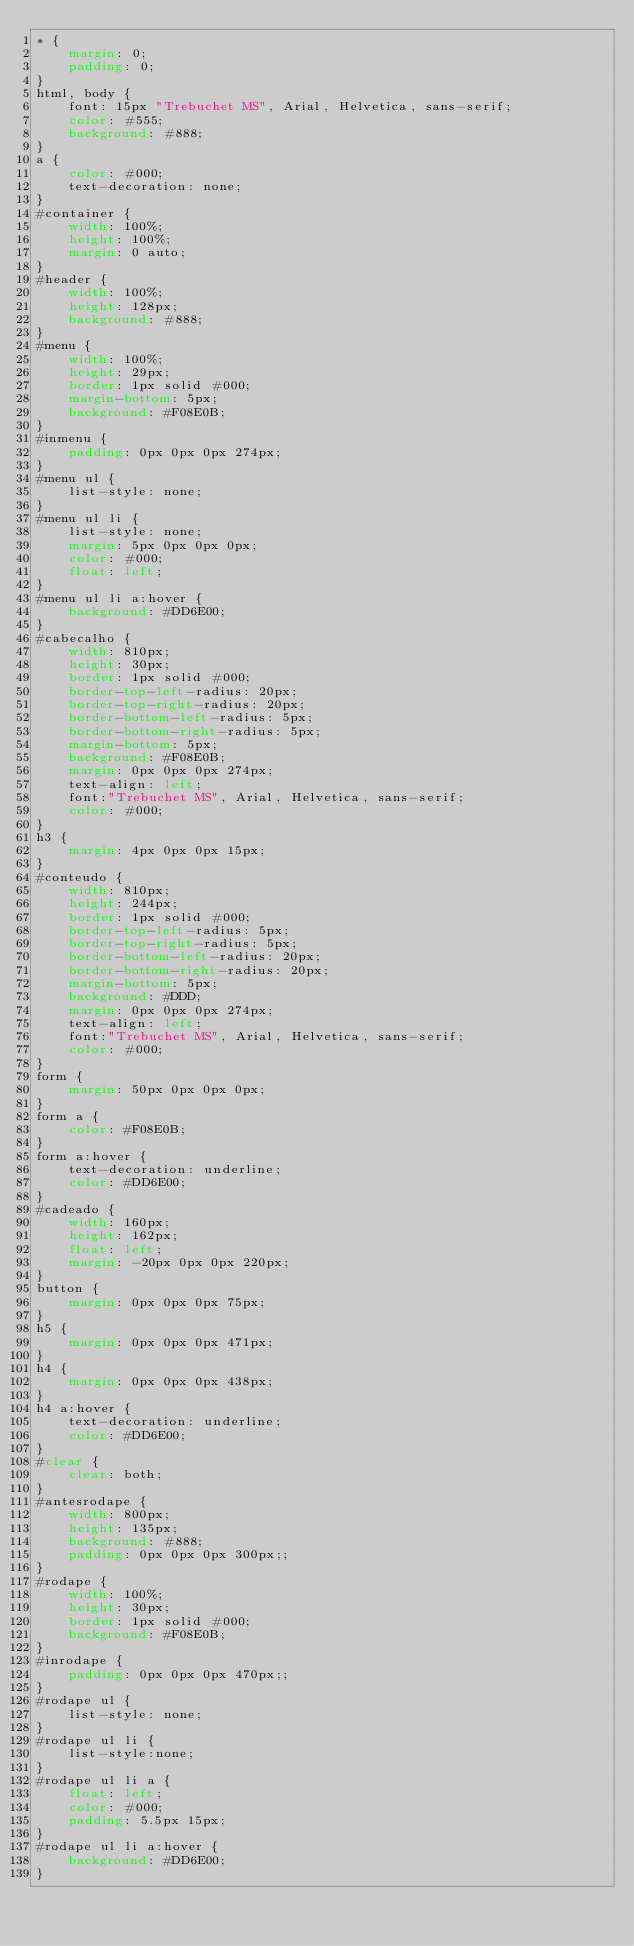Convert code to text. <code><loc_0><loc_0><loc_500><loc_500><_CSS_>* {
	margin: 0;
	padding: 0;
}
html, body {
	font: 15px "Trebuchet MS", Arial, Helvetica, sans-serif;
	color: #555;
	background: #888;
}
a {
	color: #000;
	text-decoration: none;
}
#container {
	width: 100%;
	height: 100%;
	margin: 0 auto;
}
#header {
	width: 100%;
	height: 128px;
	background: #888;
}
#menu {
	width: 100%;
	height: 29px;
	border: 1px solid #000;
	margin-bottom: 5px;
	background: #F08E0B;
}
#inmenu {
	padding: 0px 0px 0px 274px;
}
#menu ul {
	list-style: none;
}
#menu ul li {
	list-style: none;
	margin: 5px 0px 0px 0px;
	color: #000;
	float: left;
}
#menu ul li a:hover {
	background: #DD6E00;
}
#cabecalho {
	width: 810px;
	height: 30px;
	border: 1px solid #000;
	border-top-left-radius: 20px;
	border-top-right-radius: 20px;
	border-bottom-left-radius: 5px;
	border-bottom-right-radius: 5px;
	margin-bottom: 5px;
	background: #F08E0B;
	margin: 0px 0px 0px 274px;
	text-align: left;
	font:"Trebuchet MS", Arial, Helvetica, sans-serif;
	color: #000;
}
h3 {
	margin: 4px 0px 0px 15px;
}
#conteudo {
	width: 810px;
	height: 244px;
	border: 1px solid #000;
	border-top-left-radius: 5px;
	border-top-right-radius: 5px;
	border-bottom-left-radius: 20px;
	border-bottom-right-radius: 20px;
	margin-bottom: 5px;
	background: #DDD;
	margin: 0px 0px 0px 274px;
	text-align: left;
	font:"Trebuchet MS", Arial, Helvetica, sans-serif;
	color: #000;
}
form {
	margin: 50px 0px 0px 0px;
}
form a {
	color: #F08E0B;
}
form a:hover {
	text-decoration: underline;
	color: #DD6E00;
}
#cadeado {
	width: 160px;
	height: 162px;
	float: left;
	margin: -20px 0px 0px 220px;
}
button {
	margin: 0px 0px 0px 75px;
}
h5 {
	margin: 0px 0px 0px 471px;
}
h4 {
	margin: 0px 0px 0px 438px; 
}
h4 a:hover {
	text-decoration: underline;
	color: #DD6E00;
}
#clear {
	clear: both;
}
#antesrodape {
	width: 800px;
	height: 135px;
	background: #888;
	padding: 0px 0px 0px 300px;;
}
#rodape {
	width: 100%;
	height: 30px;
	border: 1px solid #000;
	background: #F08E0B;
}
#inrodape {
	padding: 0px 0px 0px 470px;;
}
#rodape ul {
	list-style: none;
}
#rodape ul li {
	list-style:none;
}
#rodape ul li a {
	float: left;
	color: #000;
	padding: 5.5px 15px;
}
#rodape ul li a:hover {
	background: #DD6E00;
}</code> 